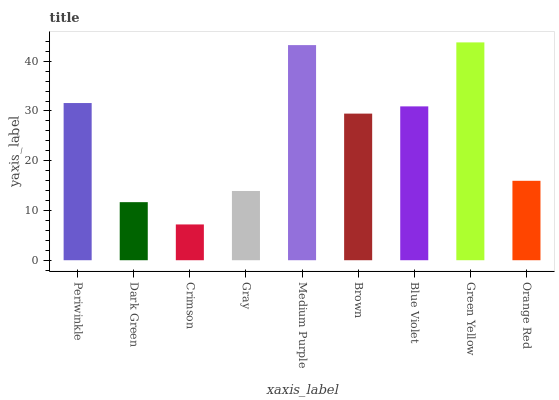Is Crimson the minimum?
Answer yes or no. Yes. Is Green Yellow the maximum?
Answer yes or no. Yes. Is Dark Green the minimum?
Answer yes or no. No. Is Dark Green the maximum?
Answer yes or no. No. Is Periwinkle greater than Dark Green?
Answer yes or no. Yes. Is Dark Green less than Periwinkle?
Answer yes or no. Yes. Is Dark Green greater than Periwinkle?
Answer yes or no. No. Is Periwinkle less than Dark Green?
Answer yes or no. No. Is Brown the high median?
Answer yes or no. Yes. Is Brown the low median?
Answer yes or no. Yes. Is Dark Green the high median?
Answer yes or no. No. Is Medium Purple the low median?
Answer yes or no. No. 